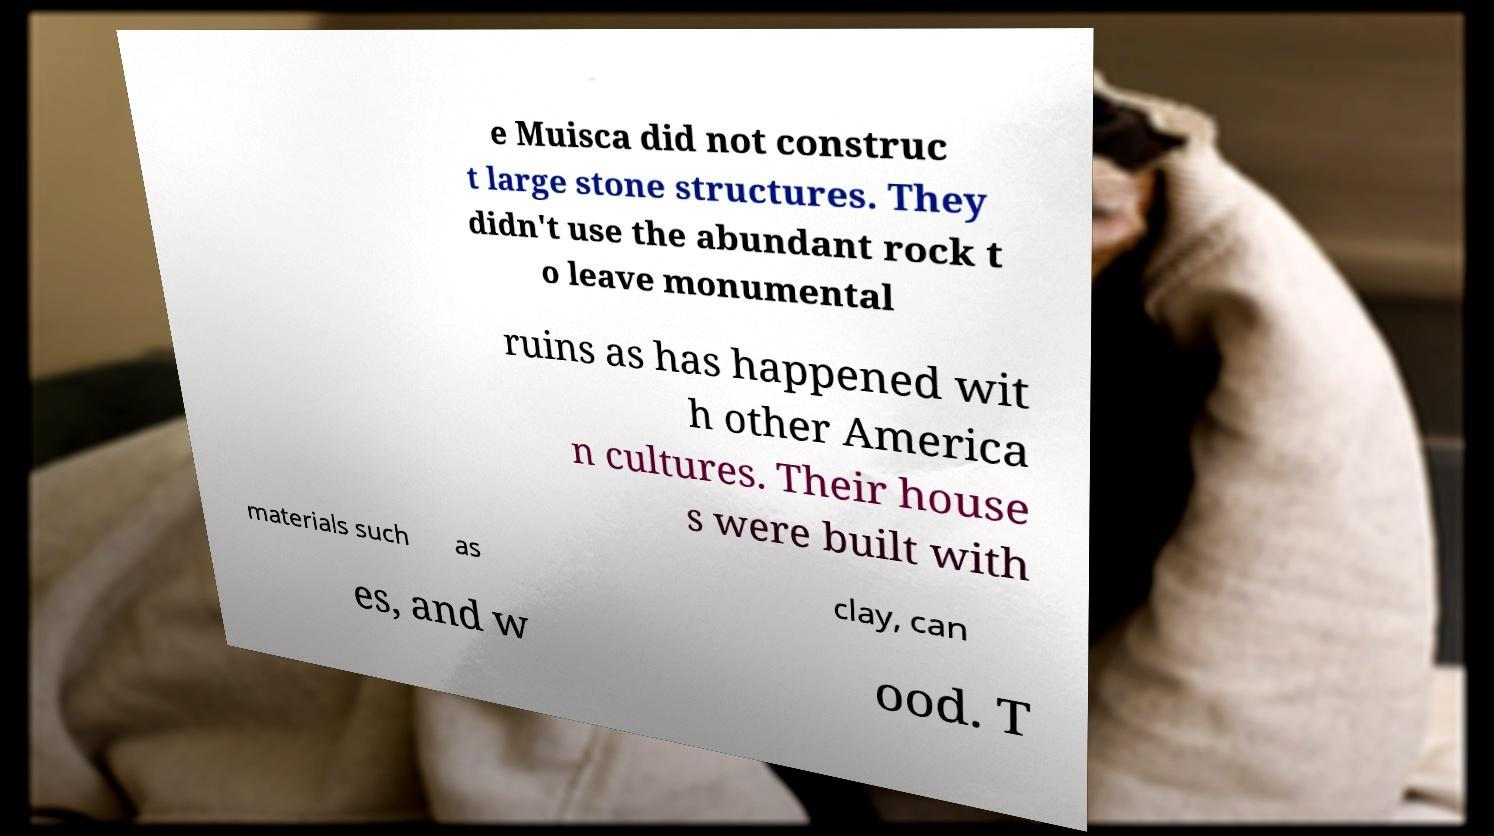I need the written content from this picture converted into text. Can you do that? e Muisca did not construc t large stone structures. They didn't use the abundant rock t o leave monumental ruins as has happened wit h other America n cultures. Their house s were built with materials such as clay, can es, and w ood. T 